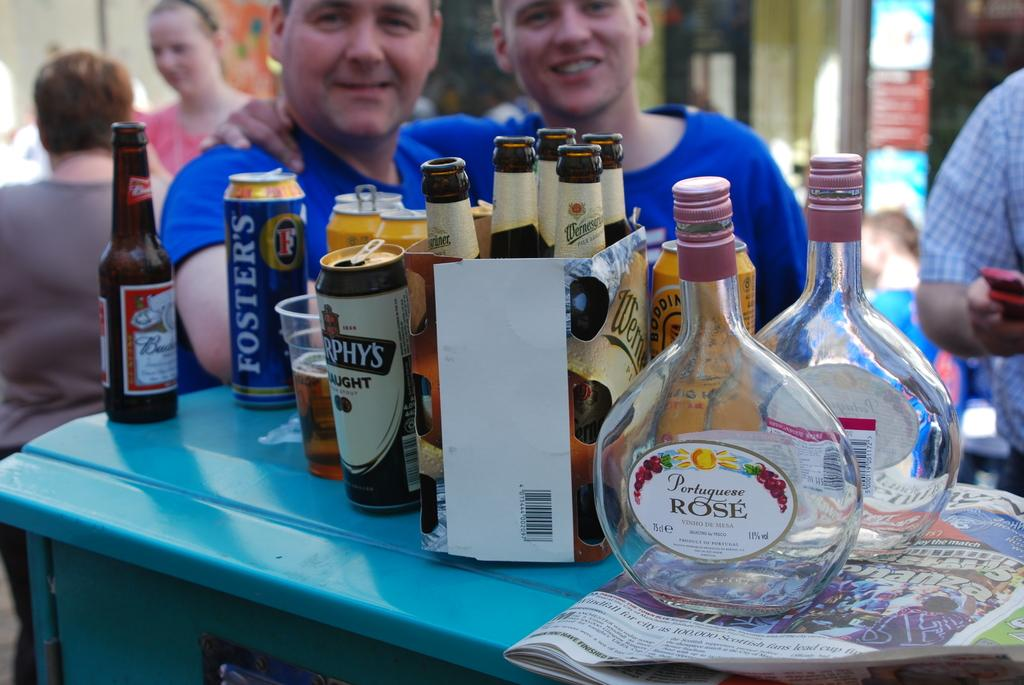<image>
Relay a brief, clear account of the picture shown. A bottle of budwiser is on a table next to a Foster's can. 